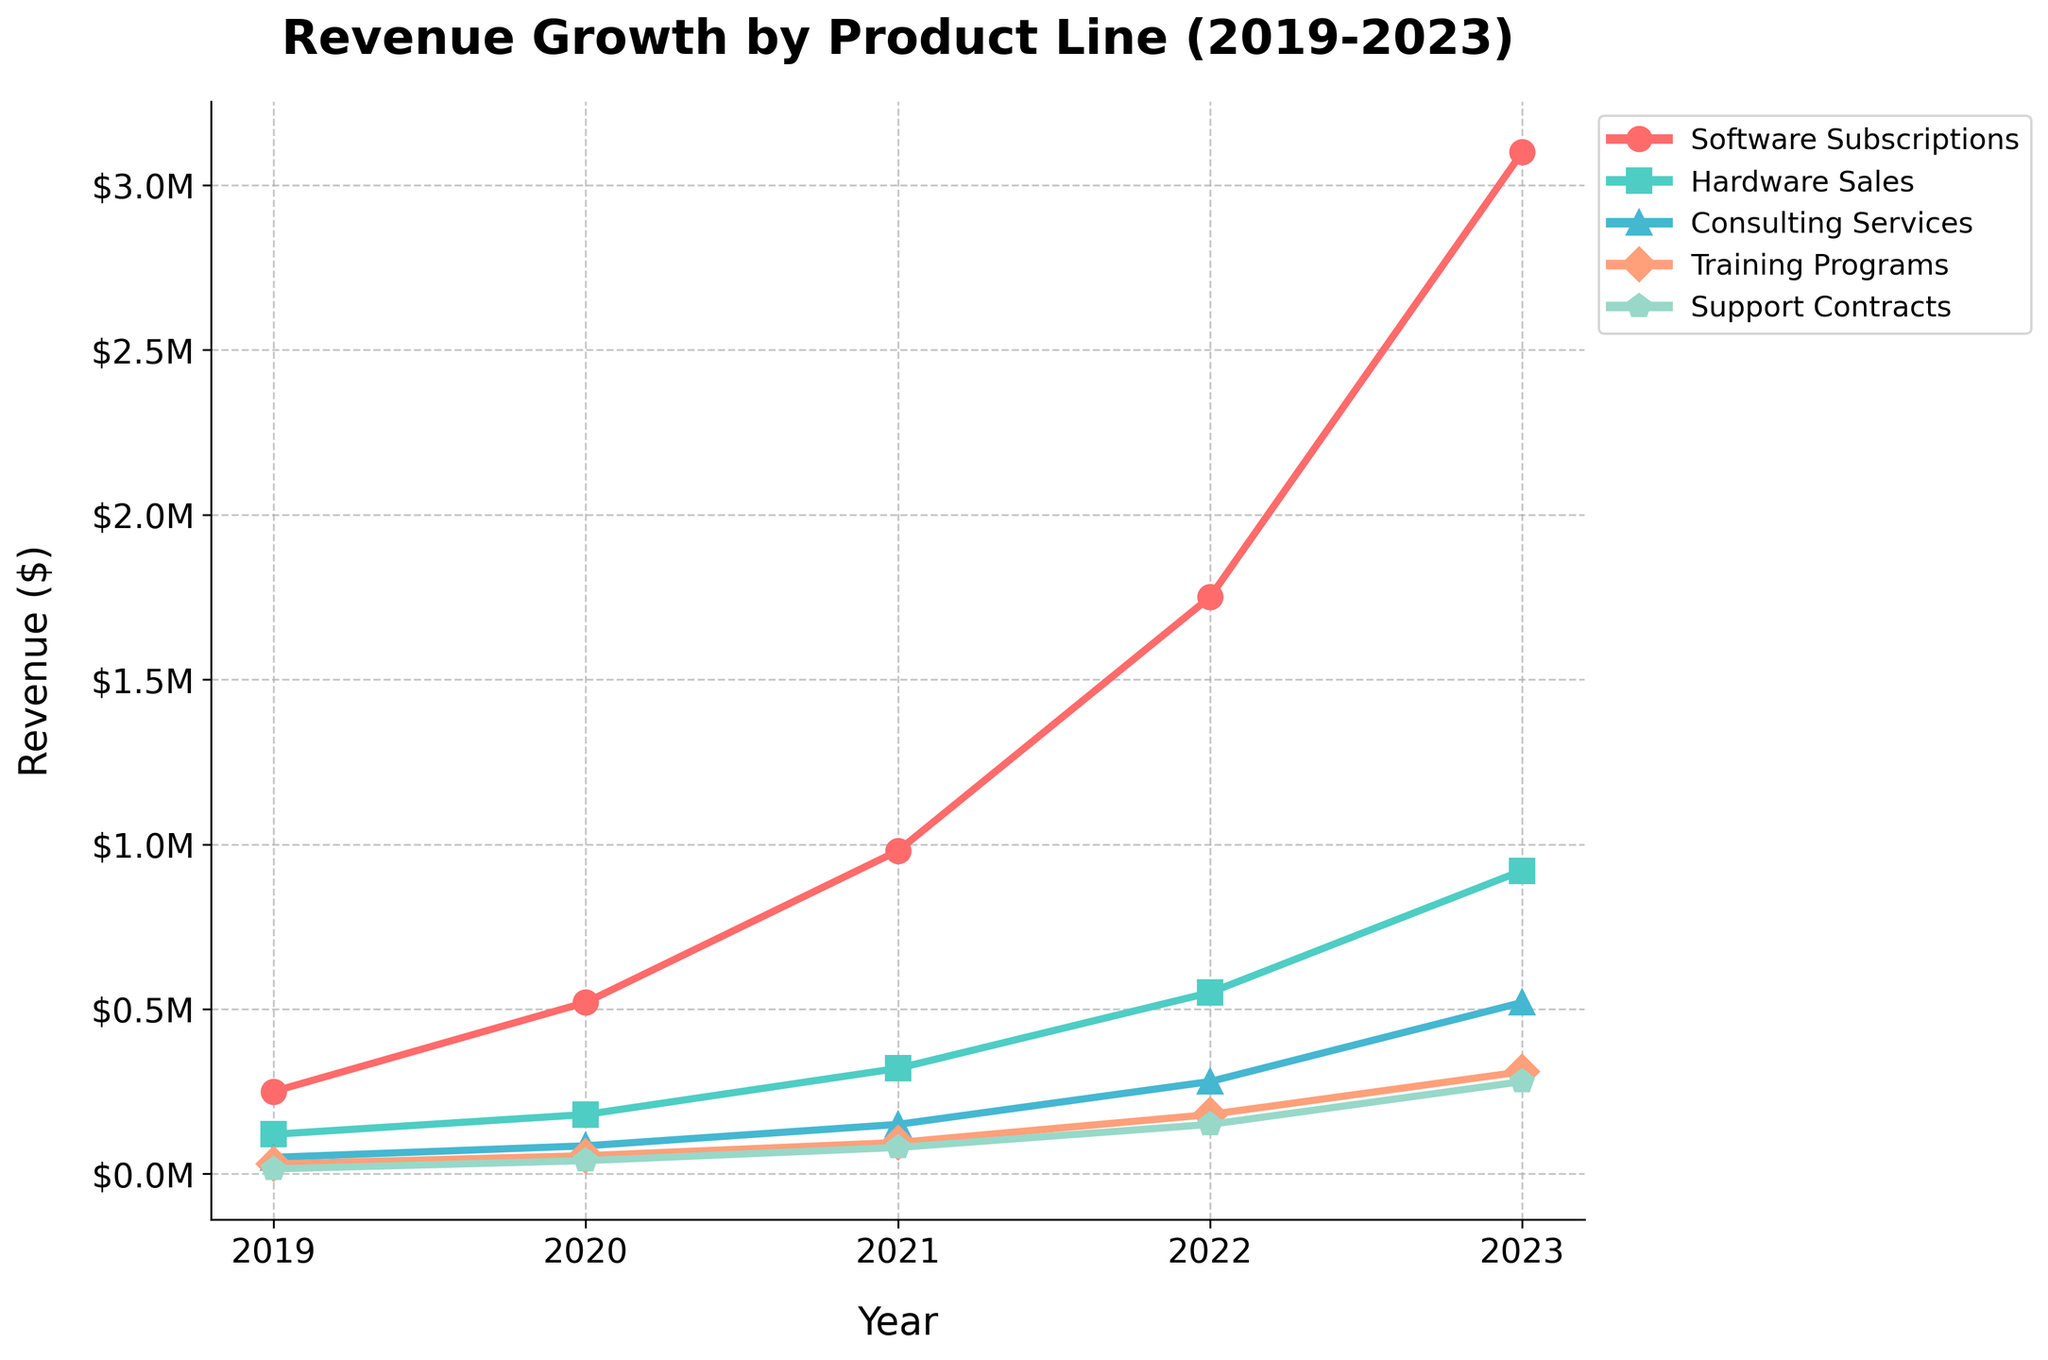Which product line had the highest revenue in 2023? To find the highest revenue in 2023, compare the values for each product line: Software Subscriptions ($3,100,000), Hardware Sales ($920,000), Consulting Services ($520,000), Training Programs ($310,000), and Support Contracts ($280,000). The highest revenue is for Software Subscriptions at $3,100,000.
Answer: Software Subscriptions How much did the revenue from Consulting Services grow from 2019 to 2022? Subtract the 2019 revenue of Consulting Services from the 2022 revenue: $280,000 (2022) - $50,000 (2019) = $230,000 growth.
Answer: $230,000 Which year saw the largest increase in revenue for Hardware Sales? Calculate the year-over-year differences: 
2020-2019: $180,000 - $120,000 = $60,000,
2021-2020: $320,000 - $180,000 = $140,000,
2022-2021: $550,000 - $320,000 = $230,000,
2023-2022: $920,000 - $550,000 = $370,000.
The largest increase is from 2022 to 2023 with $370,000.
Answer: 2023 What is the combined revenue for all product lines in 2021? Sum the revenues for all product lines in 2021: $980,000 (Software Subscriptions) + $320,000 (Hardware Sales) + $150,000 (Consulting Services) + $95,000 (Training Programs) + $80,000 (Support Contracts) = $1,625,000.
Answer: $1,625,000 Which product line had the smallest growth rate between 2019 and 2023? Calculate the growth for each product line and then compare: 
Software Subscriptions: $3,100,000 - $250,000 = $2,850,000,
Hardware Sales: $920,000 - $120,000 = $800,000,
Consulting Services: $520,000 - $50,000 = $470,000,
Training Programs: $310,000 - $30,000 = $280,000,
Support Contracts: $280,000 - $15,000 = $265,000.
Support Contracts had the smallest growth rate.
Answer: Support Contracts What is the total revenue for Training Programs over the entire period? Sum the revenues from 2019 to 2023: $30,000 (2019) + $55,000 (2020) + $95,000 (2021) + $180,000 (2022) + $310,000 (2023) = $670,000.
Answer: $670,000 Between which two consecutive years did Support Contracts see the highest percentage increase? Calculate the percentage increase for each year:
2020-2019: (($40,000 - $15,000)/$15,000)*100 ≈ 166.67%,
2021-2020: (($80,000 - $40,000)/$40,000)*100 = 100%,
2022-2021: (($150,000 - $80,000)/$80,000)*100 = 87.5%,
2023-2022: (($280,000 - $150,000)/$150,000)*100 ≈ 86.67%.
The highest percentage increase is between 2019 and 2020.
Answer: 2019-2020 What was the revenue in 2020 for the product represented by green color? Consult the colors assigned in the code and plot to identify that Hardware Sales is green, then see the 2020 revenue: $180,000.
Answer: $180,000 How much more did Software Subscriptions generate in 2023 than all product lines combined in 2020? Calculate Software Subscriptions revenue in 2023: $3,100,000. Calculate total revenue for all product lines in 2020: $520,000 + $180,000 + $85,000 + $55,000 + $40,000 = $880,000. Subtract the two: $3,100,000 - $880,000 = $2,220,000.
Answer: $2,220,000 